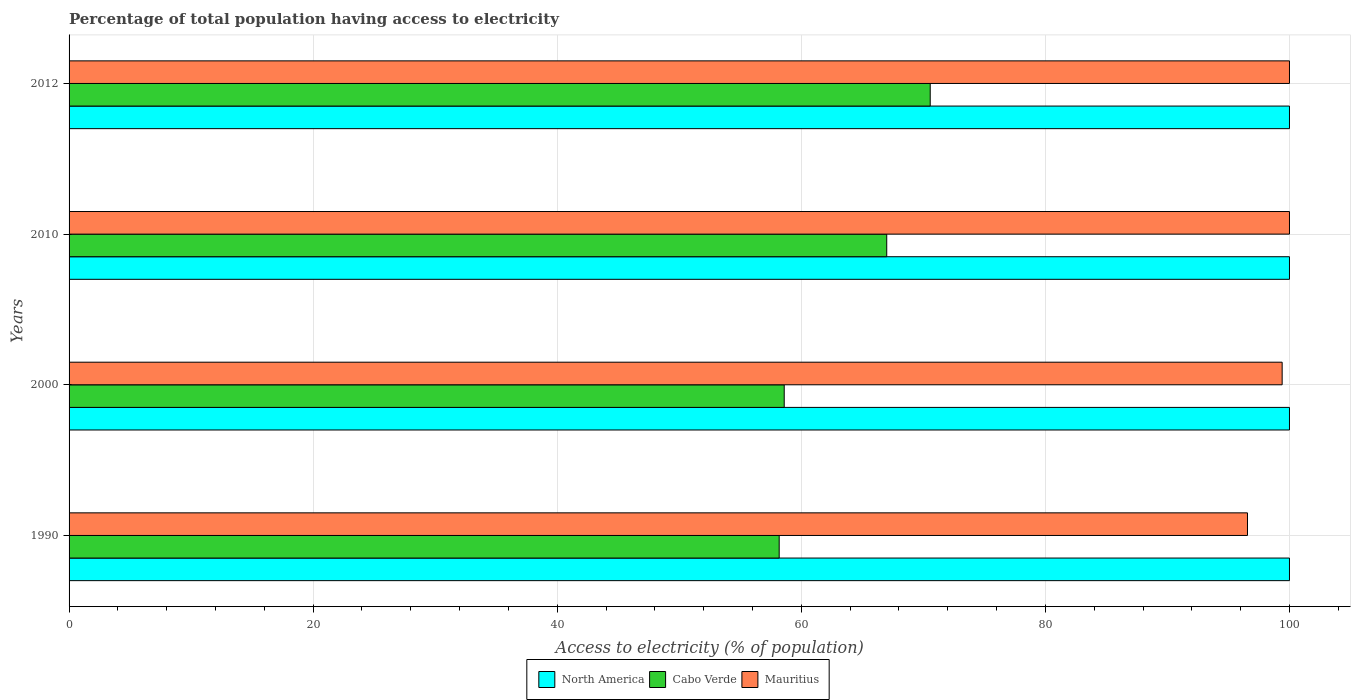What is the percentage of population that have access to electricity in Mauritius in 2000?
Give a very brief answer. 99.4. Across all years, what is the maximum percentage of population that have access to electricity in North America?
Ensure brevity in your answer.  100. Across all years, what is the minimum percentage of population that have access to electricity in Mauritius?
Offer a terse response. 96.56. What is the total percentage of population that have access to electricity in North America in the graph?
Ensure brevity in your answer.  400. What is the difference between the percentage of population that have access to electricity in Mauritius in 2000 and that in 2012?
Your response must be concise. -0.6. What is the difference between the percentage of population that have access to electricity in Cabo Verde in 2010 and the percentage of population that have access to electricity in North America in 2012?
Offer a very short reply. -33. What is the average percentage of population that have access to electricity in Cabo Verde per year?
Your answer should be very brief. 63.59. In the year 2012, what is the difference between the percentage of population that have access to electricity in North America and percentage of population that have access to electricity in Cabo Verde?
Give a very brief answer. 29.44. What is the ratio of the percentage of population that have access to electricity in Mauritius in 2010 to that in 2012?
Provide a succinct answer. 1. Is the difference between the percentage of population that have access to electricity in North America in 2000 and 2010 greater than the difference between the percentage of population that have access to electricity in Cabo Verde in 2000 and 2010?
Provide a succinct answer. Yes. What is the difference between the highest and the second highest percentage of population that have access to electricity in Cabo Verde?
Ensure brevity in your answer.  3.56. What is the difference between the highest and the lowest percentage of population that have access to electricity in Mauritius?
Make the answer very short. 3.44. In how many years, is the percentage of population that have access to electricity in Cabo Verde greater than the average percentage of population that have access to electricity in Cabo Verde taken over all years?
Your answer should be very brief. 2. What does the 1st bar from the bottom in 2000 represents?
Give a very brief answer. North America. Is it the case that in every year, the sum of the percentage of population that have access to electricity in North America and percentage of population that have access to electricity in Cabo Verde is greater than the percentage of population that have access to electricity in Mauritius?
Offer a terse response. Yes. How many bars are there?
Keep it short and to the point. 12. Are all the bars in the graph horizontal?
Offer a very short reply. Yes. What is the difference between two consecutive major ticks on the X-axis?
Make the answer very short. 20. Does the graph contain any zero values?
Ensure brevity in your answer.  No. Does the graph contain grids?
Offer a very short reply. Yes. Where does the legend appear in the graph?
Offer a terse response. Bottom center. What is the title of the graph?
Your response must be concise. Percentage of total population having access to electricity. What is the label or title of the X-axis?
Offer a very short reply. Access to electricity (% of population). What is the Access to electricity (% of population) of Cabo Verde in 1990?
Your answer should be very brief. 58.19. What is the Access to electricity (% of population) in Mauritius in 1990?
Keep it short and to the point. 96.56. What is the Access to electricity (% of population) of North America in 2000?
Your answer should be compact. 100. What is the Access to electricity (% of population) of Cabo Verde in 2000?
Ensure brevity in your answer.  58.6. What is the Access to electricity (% of population) of Mauritius in 2000?
Offer a very short reply. 99.4. What is the Access to electricity (% of population) in North America in 2010?
Offer a very short reply. 100. What is the Access to electricity (% of population) in Cabo Verde in 2010?
Make the answer very short. 67. What is the Access to electricity (% of population) in Mauritius in 2010?
Your response must be concise. 100. What is the Access to electricity (% of population) in North America in 2012?
Your answer should be compact. 100. What is the Access to electricity (% of population) in Cabo Verde in 2012?
Provide a short and direct response. 70.56. What is the Access to electricity (% of population) in Mauritius in 2012?
Offer a very short reply. 100. Across all years, what is the maximum Access to electricity (% of population) in North America?
Give a very brief answer. 100. Across all years, what is the maximum Access to electricity (% of population) of Cabo Verde?
Your response must be concise. 70.56. Across all years, what is the maximum Access to electricity (% of population) in Mauritius?
Make the answer very short. 100. Across all years, what is the minimum Access to electricity (% of population) in North America?
Your response must be concise. 100. Across all years, what is the minimum Access to electricity (% of population) of Cabo Verde?
Make the answer very short. 58.19. Across all years, what is the minimum Access to electricity (% of population) of Mauritius?
Your response must be concise. 96.56. What is the total Access to electricity (% of population) of North America in the graph?
Provide a succinct answer. 400. What is the total Access to electricity (% of population) in Cabo Verde in the graph?
Offer a terse response. 254.35. What is the total Access to electricity (% of population) of Mauritius in the graph?
Give a very brief answer. 395.96. What is the difference between the Access to electricity (% of population) of Cabo Verde in 1990 and that in 2000?
Keep it short and to the point. -0.41. What is the difference between the Access to electricity (% of population) in Mauritius in 1990 and that in 2000?
Your answer should be compact. -2.84. What is the difference between the Access to electricity (% of population) of North America in 1990 and that in 2010?
Offer a terse response. 0. What is the difference between the Access to electricity (% of population) of Cabo Verde in 1990 and that in 2010?
Give a very brief answer. -8.81. What is the difference between the Access to electricity (% of population) in Mauritius in 1990 and that in 2010?
Provide a short and direct response. -3.44. What is the difference between the Access to electricity (% of population) in Cabo Verde in 1990 and that in 2012?
Provide a short and direct response. -12.37. What is the difference between the Access to electricity (% of population) of Mauritius in 1990 and that in 2012?
Your answer should be very brief. -3.44. What is the difference between the Access to electricity (% of population) in Cabo Verde in 2000 and that in 2010?
Offer a very short reply. -8.4. What is the difference between the Access to electricity (% of population) in Cabo Verde in 2000 and that in 2012?
Give a very brief answer. -11.96. What is the difference between the Access to electricity (% of population) of Mauritius in 2000 and that in 2012?
Your answer should be compact. -0.6. What is the difference between the Access to electricity (% of population) in Cabo Verde in 2010 and that in 2012?
Provide a short and direct response. -3.56. What is the difference between the Access to electricity (% of population) in North America in 1990 and the Access to electricity (% of population) in Cabo Verde in 2000?
Offer a very short reply. 41.4. What is the difference between the Access to electricity (% of population) of Cabo Verde in 1990 and the Access to electricity (% of population) of Mauritius in 2000?
Your answer should be compact. -41.21. What is the difference between the Access to electricity (% of population) of North America in 1990 and the Access to electricity (% of population) of Mauritius in 2010?
Your response must be concise. 0. What is the difference between the Access to electricity (% of population) in Cabo Verde in 1990 and the Access to electricity (% of population) in Mauritius in 2010?
Provide a succinct answer. -41.81. What is the difference between the Access to electricity (% of population) in North America in 1990 and the Access to electricity (% of population) in Cabo Verde in 2012?
Your answer should be very brief. 29.44. What is the difference between the Access to electricity (% of population) in Cabo Verde in 1990 and the Access to electricity (% of population) in Mauritius in 2012?
Provide a short and direct response. -41.81. What is the difference between the Access to electricity (% of population) of North America in 2000 and the Access to electricity (% of population) of Cabo Verde in 2010?
Your answer should be compact. 33. What is the difference between the Access to electricity (% of population) in North America in 2000 and the Access to electricity (% of population) in Mauritius in 2010?
Your answer should be compact. 0. What is the difference between the Access to electricity (% of population) in Cabo Verde in 2000 and the Access to electricity (% of population) in Mauritius in 2010?
Offer a terse response. -41.4. What is the difference between the Access to electricity (% of population) in North America in 2000 and the Access to electricity (% of population) in Cabo Verde in 2012?
Your answer should be very brief. 29.44. What is the difference between the Access to electricity (% of population) of North America in 2000 and the Access to electricity (% of population) of Mauritius in 2012?
Give a very brief answer. 0. What is the difference between the Access to electricity (% of population) in Cabo Verde in 2000 and the Access to electricity (% of population) in Mauritius in 2012?
Your answer should be compact. -41.4. What is the difference between the Access to electricity (% of population) of North America in 2010 and the Access to electricity (% of population) of Cabo Verde in 2012?
Offer a very short reply. 29.44. What is the difference between the Access to electricity (% of population) in North America in 2010 and the Access to electricity (% of population) in Mauritius in 2012?
Provide a short and direct response. 0. What is the difference between the Access to electricity (% of population) in Cabo Verde in 2010 and the Access to electricity (% of population) in Mauritius in 2012?
Provide a short and direct response. -33. What is the average Access to electricity (% of population) of North America per year?
Ensure brevity in your answer.  100. What is the average Access to electricity (% of population) of Cabo Verde per year?
Offer a terse response. 63.59. What is the average Access to electricity (% of population) in Mauritius per year?
Give a very brief answer. 98.99. In the year 1990, what is the difference between the Access to electricity (% of population) of North America and Access to electricity (% of population) of Cabo Verde?
Provide a short and direct response. 41.81. In the year 1990, what is the difference between the Access to electricity (% of population) of North America and Access to electricity (% of population) of Mauritius?
Provide a succinct answer. 3.44. In the year 1990, what is the difference between the Access to electricity (% of population) in Cabo Verde and Access to electricity (% of population) in Mauritius?
Keep it short and to the point. -38.37. In the year 2000, what is the difference between the Access to electricity (% of population) in North America and Access to electricity (% of population) in Cabo Verde?
Offer a very short reply. 41.4. In the year 2000, what is the difference between the Access to electricity (% of population) of North America and Access to electricity (% of population) of Mauritius?
Keep it short and to the point. 0.6. In the year 2000, what is the difference between the Access to electricity (% of population) in Cabo Verde and Access to electricity (% of population) in Mauritius?
Provide a short and direct response. -40.8. In the year 2010, what is the difference between the Access to electricity (% of population) in North America and Access to electricity (% of population) in Cabo Verde?
Keep it short and to the point. 33. In the year 2010, what is the difference between the Access to electricity (% of population) in Cabo Verde and Access to electricity (% of population) in Mauritius?
Provide a short and direct response. -33. In the year 2012, what is the difference between the Access to electricity (% of population) in North America and Access to electricity (% of population) in Cabo Verde?
Provide a short and direct response. 29.44. In the year 2012, what is the difference between the Access to electricity (% of population) in Cabo Verde and Access to electricity (% of population) in Mauritius?
Your answer should be very brief. -29.44. What is the ratio of the Access to electricity (% of population) of North America in 1990 to that in 2000?
Your answer should be compact. 1. What is the ratio of the Access to electricity (% of population) in Cabo Verde in 1990 to that in 2000?
Offer a very short reply. 0.99. What is the ratio of the Access to electricity (% of population) in Mauritius in 1990 to that in 2000?
Offer a very short reply. 0.97. What is the ratio of the Access to electricity (% of population) of Cabo Verde in 1990 to that in 2010?
Keep it short and to the point. 0.87. What is the ratio of the Access to electricity (% of population) in Mauritius in 1990 to that in 2010?
Make the answer very short. 0.97. What is the ratio of the Access to electricity (% of population) of Cabo Verde in 1990 to that in 2012?
Offer a very short reply. 0.82. What is the ratio of the Access to electricity (% of population) in Mauritius in 1990 to that in 2012?
Provide a succinct answer. 0.97. What is the ratio of the Access to electricity (% of population) in North America in 2000 to that in 2010?
Make the answer very short. 1. What is the ratio of the Access to electricity (% of population) of Cabo Verde in 2000 to that in 2010?
Your answer should be very brief. 0.87. What is the ratio of the Access to electricity (% of population) in Mauritius in 2000 to that in 2010?
Your answer should be compact. 0.99. What is the ratio of the Access to electricity (% of population) in Cabo Verde in 2000 to that in 2012?
Offer a terse response. 0.83. What is the ratio of the Access to electricity (% of population) of Cabo Verde in 2010 to that in 2012?
Make the answer very short. 0.95. What is the difference between the highest and the second highest Access to electricity (% of population) of North America?
Offer a terse response. 0. What is the difference between the highest and the second highest Access to electricity (% of population) in Cabo Verde?
Provide a succinct answer. 3.56. What is the difference between the highest and the lowest Access to electricity (% of population) of North America?
Your response must be concise. 0. What is the difference between the highest and the lowest Access to electricity (% of population) in Cabo Verde?
Offer a very short reply. 12.37. What is the difference between the highest and the lowest Access to electricity (% of population) in Mauritius?
Your answer should be very brief. 3.44. 